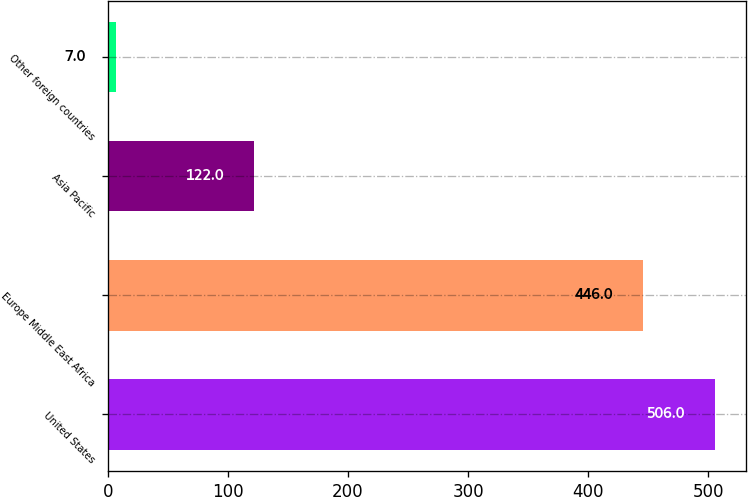Convert chart to OTSL. <chart><loc_0><loc_0><loc_500><loc_500><bar_chart><fcel>United States<fcel>Europe Middle East Africa<fcel>Asia Pacific<fcel>Other foreign countries<nl><fcel>506<fcel>446<fcel>122<fcel>7<nl></chart> 